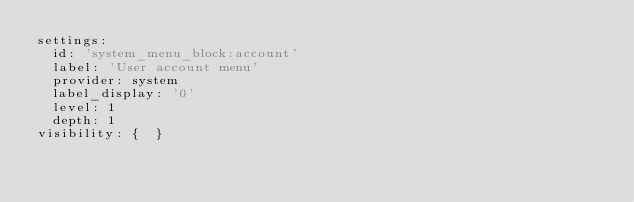Convert code to text. <code><loc_0><loc_0><loc_500><loc_500><_YAML_>settings:
  id: 'system_menu_block:account'
  label: 'User account menu'
  provider: system
  label_display: '0'
  level: 1
  depth: 1
visibility: {  }
</code> 